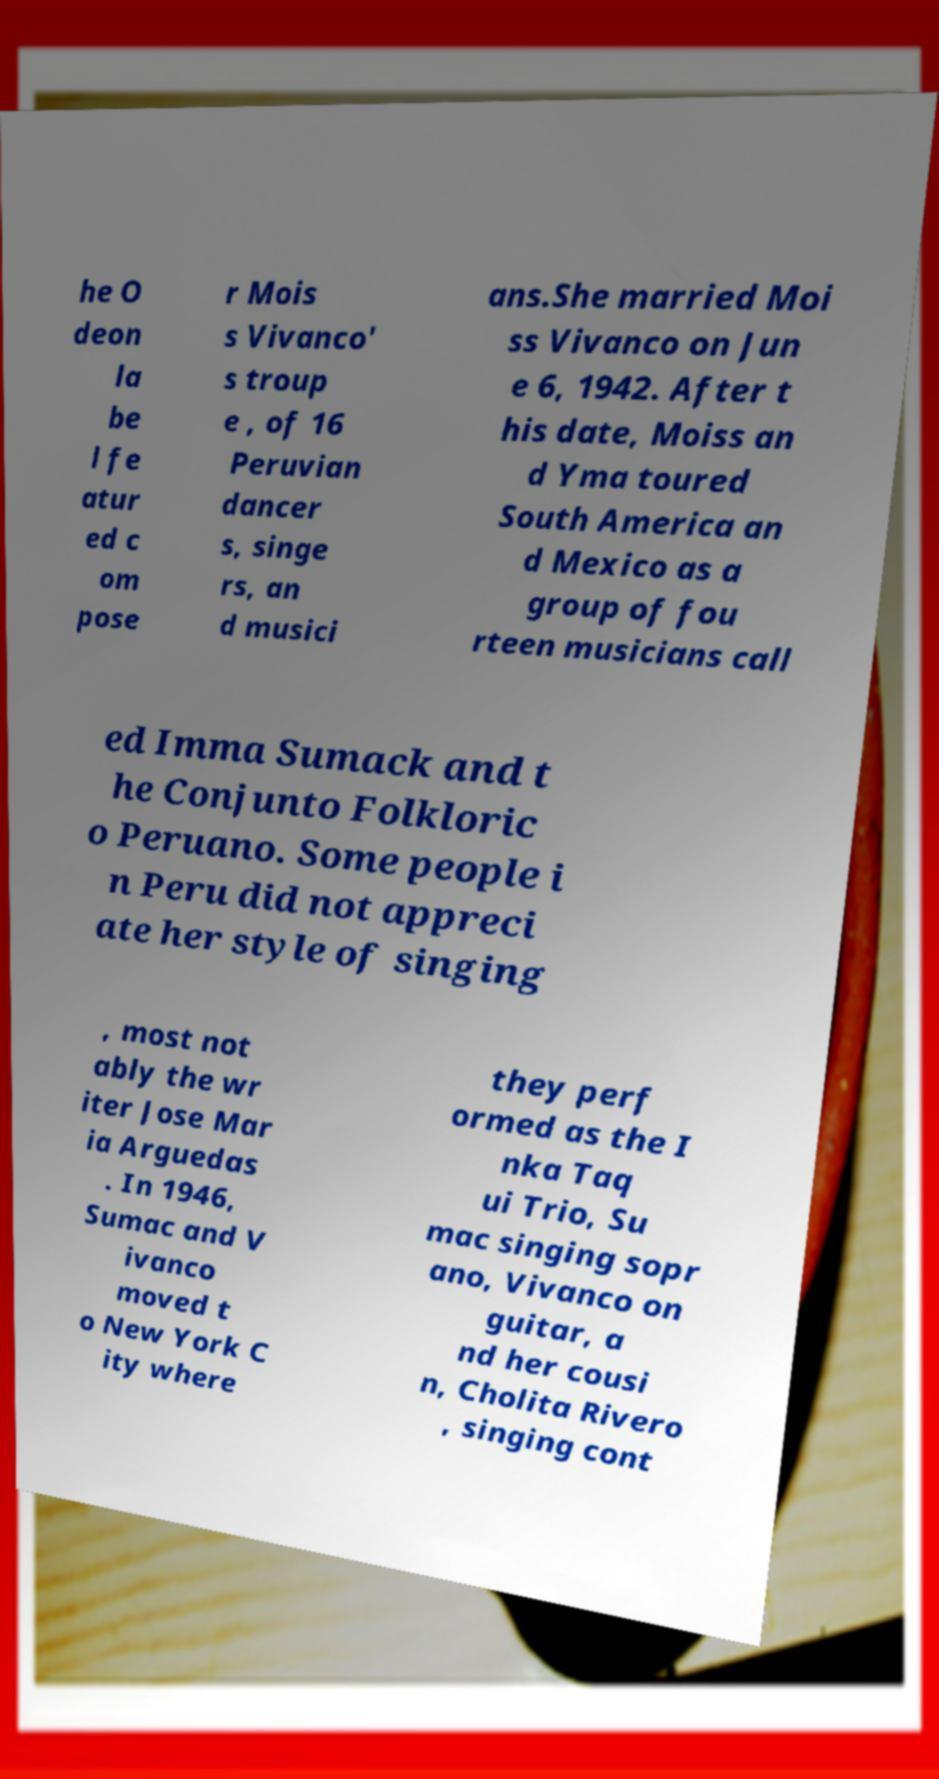I need the written content from this picture converted into text. Can you do that? he O deon la be l fe atur ed c om pose r Mois s Vivanco' s troup e , of 16 Peruvian dancer s, singe rs, an d musici ans.She married Moi ss Vivanco on Jun e 6, 1942. After t his date, Moiss an d Yma toured South America an d Mexico as a group of fou rteen musicians call ed Imma Sumack and t he Conjunto Folkloric o Peruano. Some people i n Peru did not appreci ate her style of singing , most not ably the wr iter Jose Mar ia Arguedas . In 1946, Sumac and V ivanco moved t o New York C ity where they perf ormed as the I nka Taq ui Trio, Su mac singing sopr ano, Vivanco on guitar, a nd her cousi n, Cholita Rivero , singing cont 